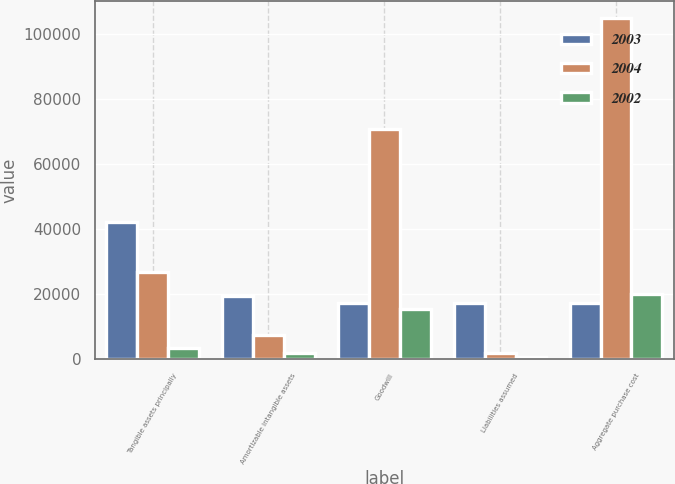Convert chart to OTSL. <chart><loc_0><loc_0><loc_500><loc_500><stacked_bar_chart><ecel><fcel>Tangible assets principally<fcel>Amortizable intangible assets<fcel>Goodwill<fcel>Liabilities assumed<fcel>Aggregate purchase cost<nl><fcel>2003<fcel>42155<fcel>19471<fcel>17356<fcel>17356<fcel>17356<nl><fcel>2004<fcel>26678<fcel>7273<fcel>70700<fcel>1777<fcel>104791<nl><fcel>2002<fcel>3360<fcel>1975<fcel>15260<fcel>518<fcel>20077<nl></chart> 